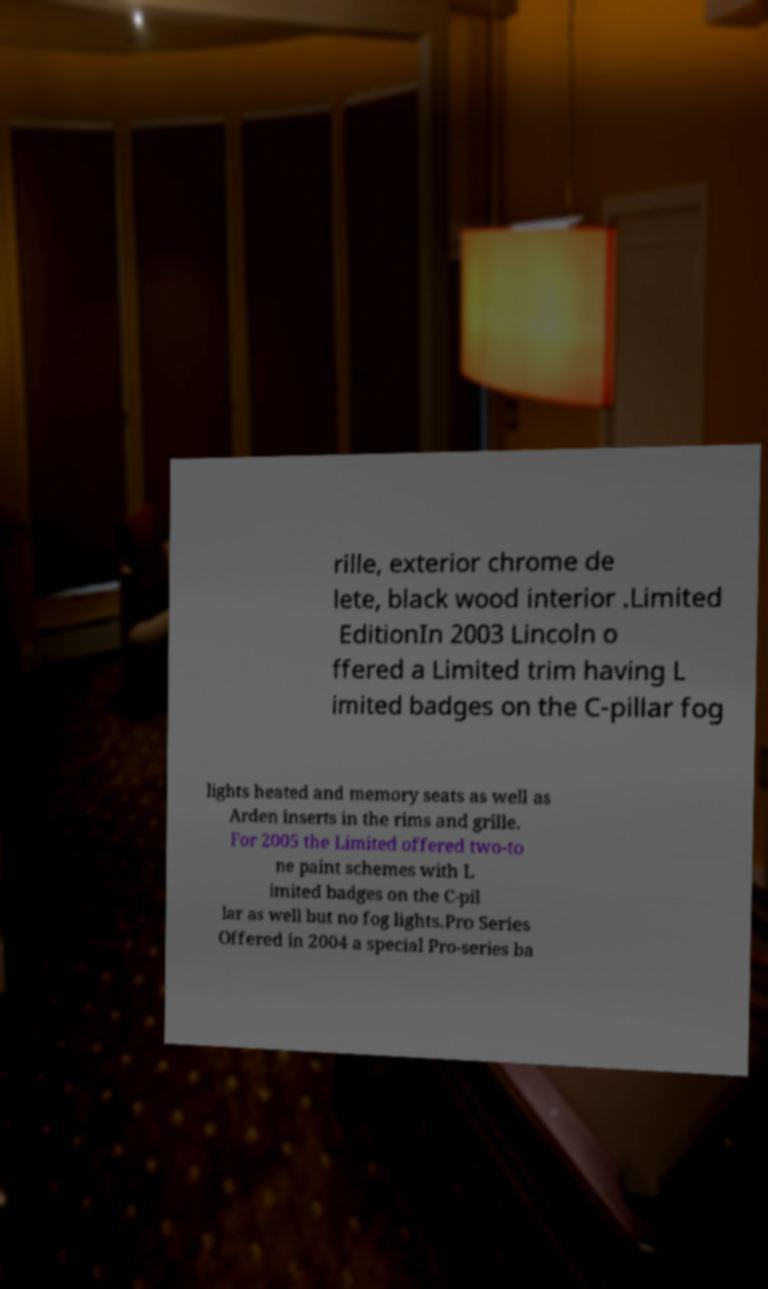Can you accurately transcribe the text from the provided image for me? rille, exterior chrome de lete, black wood interior .Limited EditionIn 2003 Lincoln o ffered a Limited trim having L imited badges on the C-pillar fog lights heated and memory seats as well as Arden inserts in the rims and grille. For 2005 the Limited offered two-to ne paint schemes with L imited badges on the C-pil lar as well but no fog lights.Pro Series Offered in 2004 a special Pro-series ba 